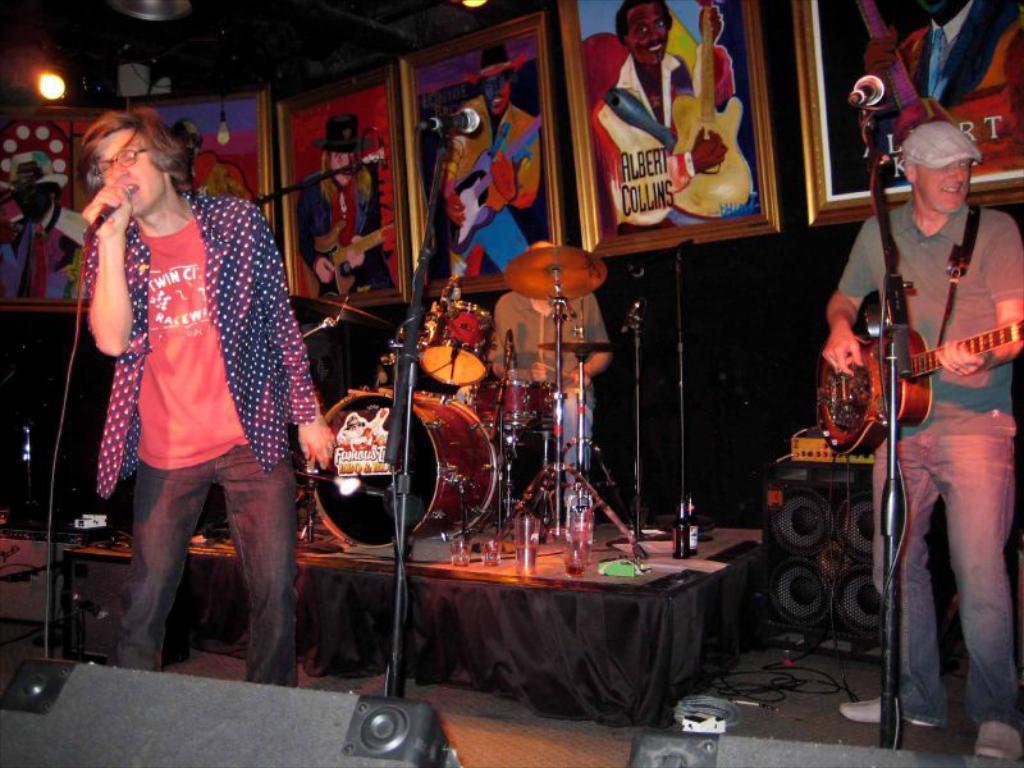Describe this image in one or two sentences. there are two persons one person is playing guitar another person is singing in a microphone 